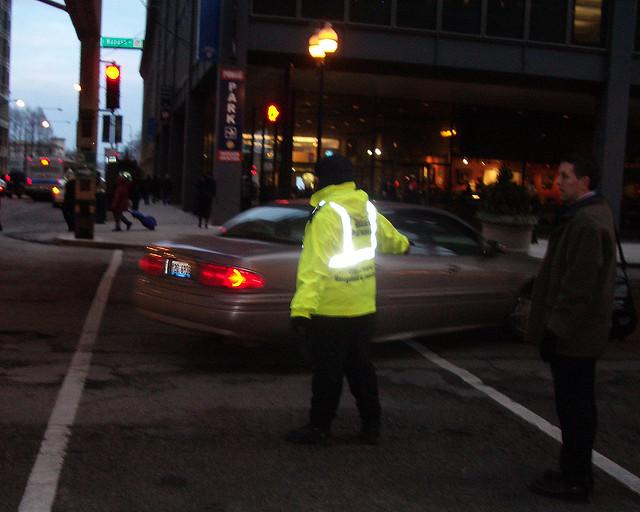What is the man in yellow doing?
Be succinct. Directing traffic. What is the license plate number?
Quick response, please. Letters. Are the streetlights on?
Keep it brief. Yes. What kind of vehicle is shown?
Quick response, please. Car. 